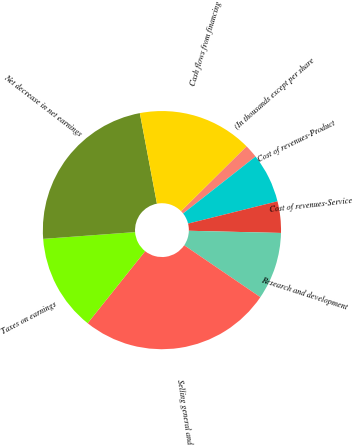Convert chart. <chart><loc_0><loc_0><loc_500><loc_500><pie_chart><fcel>(In thousands except per share<fcel>Cost of revenues-Product<fcel>Cost of revenues-Service<fcel>Research and development<fcel>Selling general and<fcel>Taxes on earnings<fcel>Net decrease in net earnings<fcel>Cash flows from financing<nl><fcel>1.83%<fcel>6.71%<fcel>4.27%<fcel>9.14%<fcel>26.2%<fcel>13.11%<fcel>23.2%<fcel>15.54%<nl></chart> 